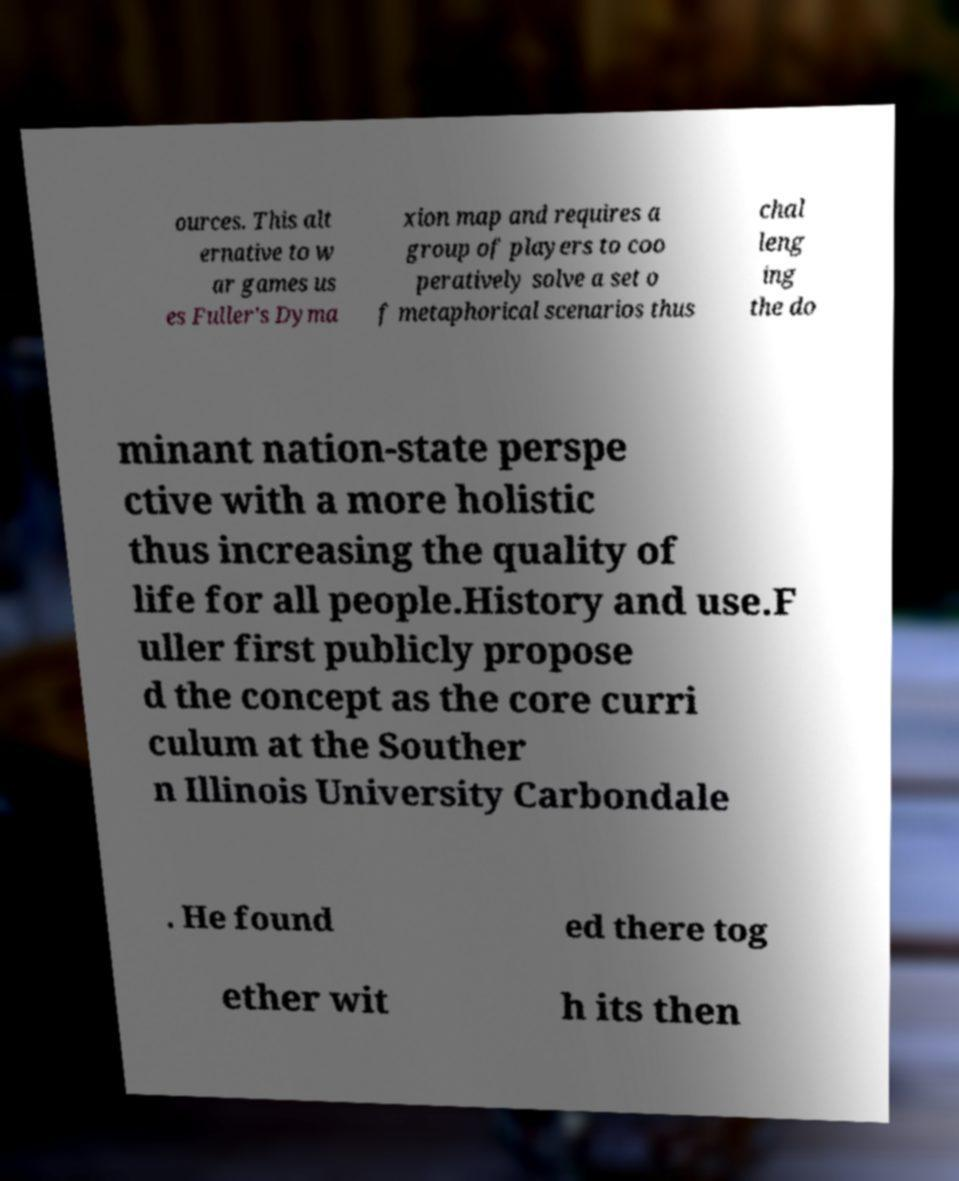Can you read and provide the text displayed in the image?This photo seems to have some interesting text. Can you extract and type it out for me? ources. This alt ernative to w ar games us es Fuller's Dyma xion map and requires a group of players to coo peratively solve a set o f metaphorical scenarios thus chal leng ing the do minant nation-state perspe ctive with a more holistic thus increasing the quality of life for all people.History and use.F uller first publicly propose d the concept as the core curri culum at the Souther n Illinois University Carbondale . He found ed there tog ether wit h its then 